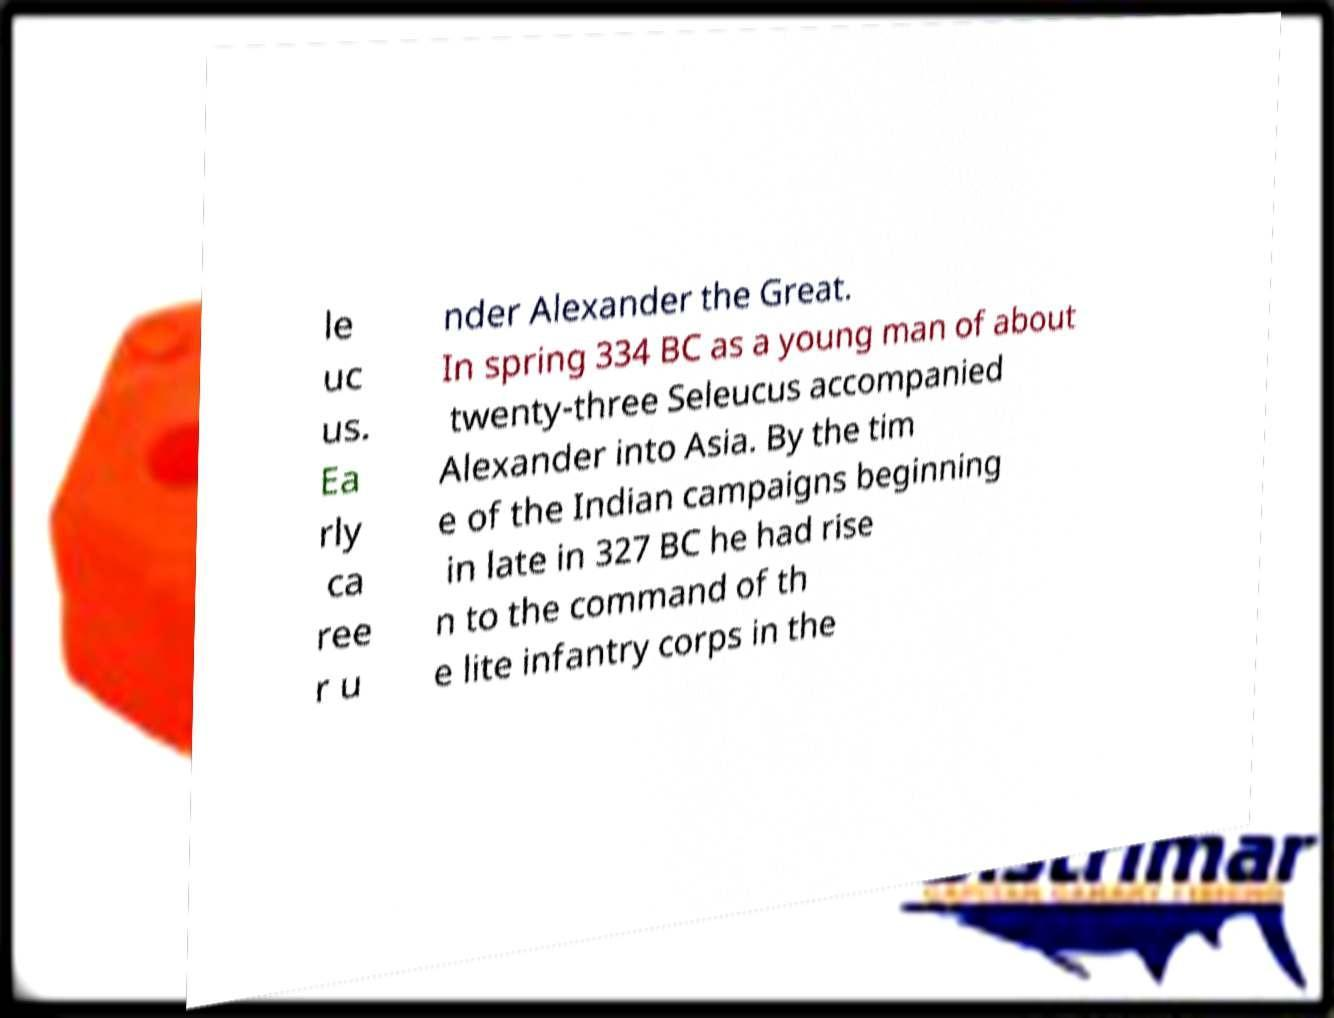Please read and relay the text visible in this image. What does it say? le uc us. Ea rly ca ree r u nder Alexander the Great. In spring 334 BC as a young man of about twenty-three Seleucus accompanied Alexander into Asia. By the tim e of the Indian campaigns beginning in late in 327 BC he had rise n to the command of th e lite infantry corps in the 